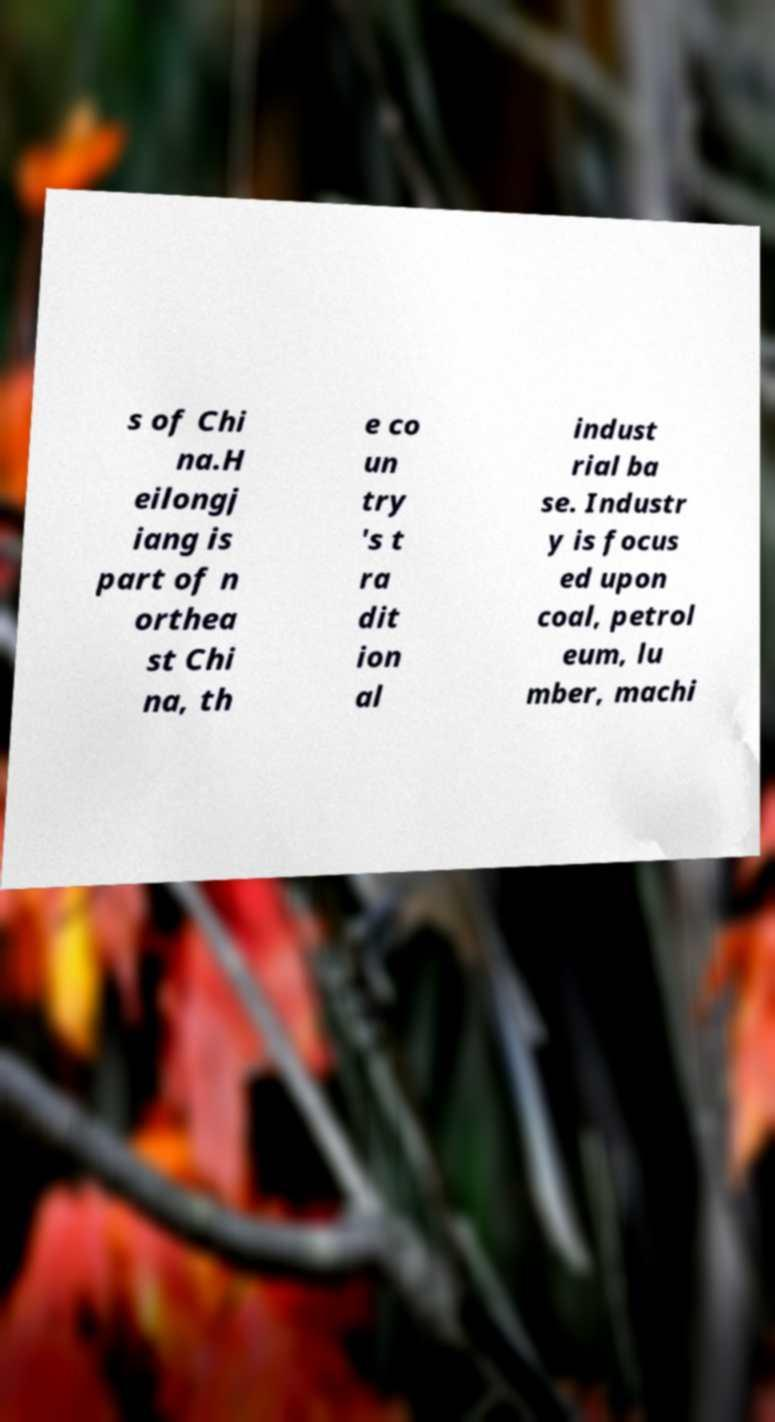Can you read and provide the text displayed in the image?This photo seems to have some interesting text. Can you extract and type it out for me? s of Chi na.H eilongj iang is part of n orthea st Chi na, th e co un try 's t ra dit ion al indust rial ba se. Industr y is focus ed upon coal, petrol eum, lu mber, machi 